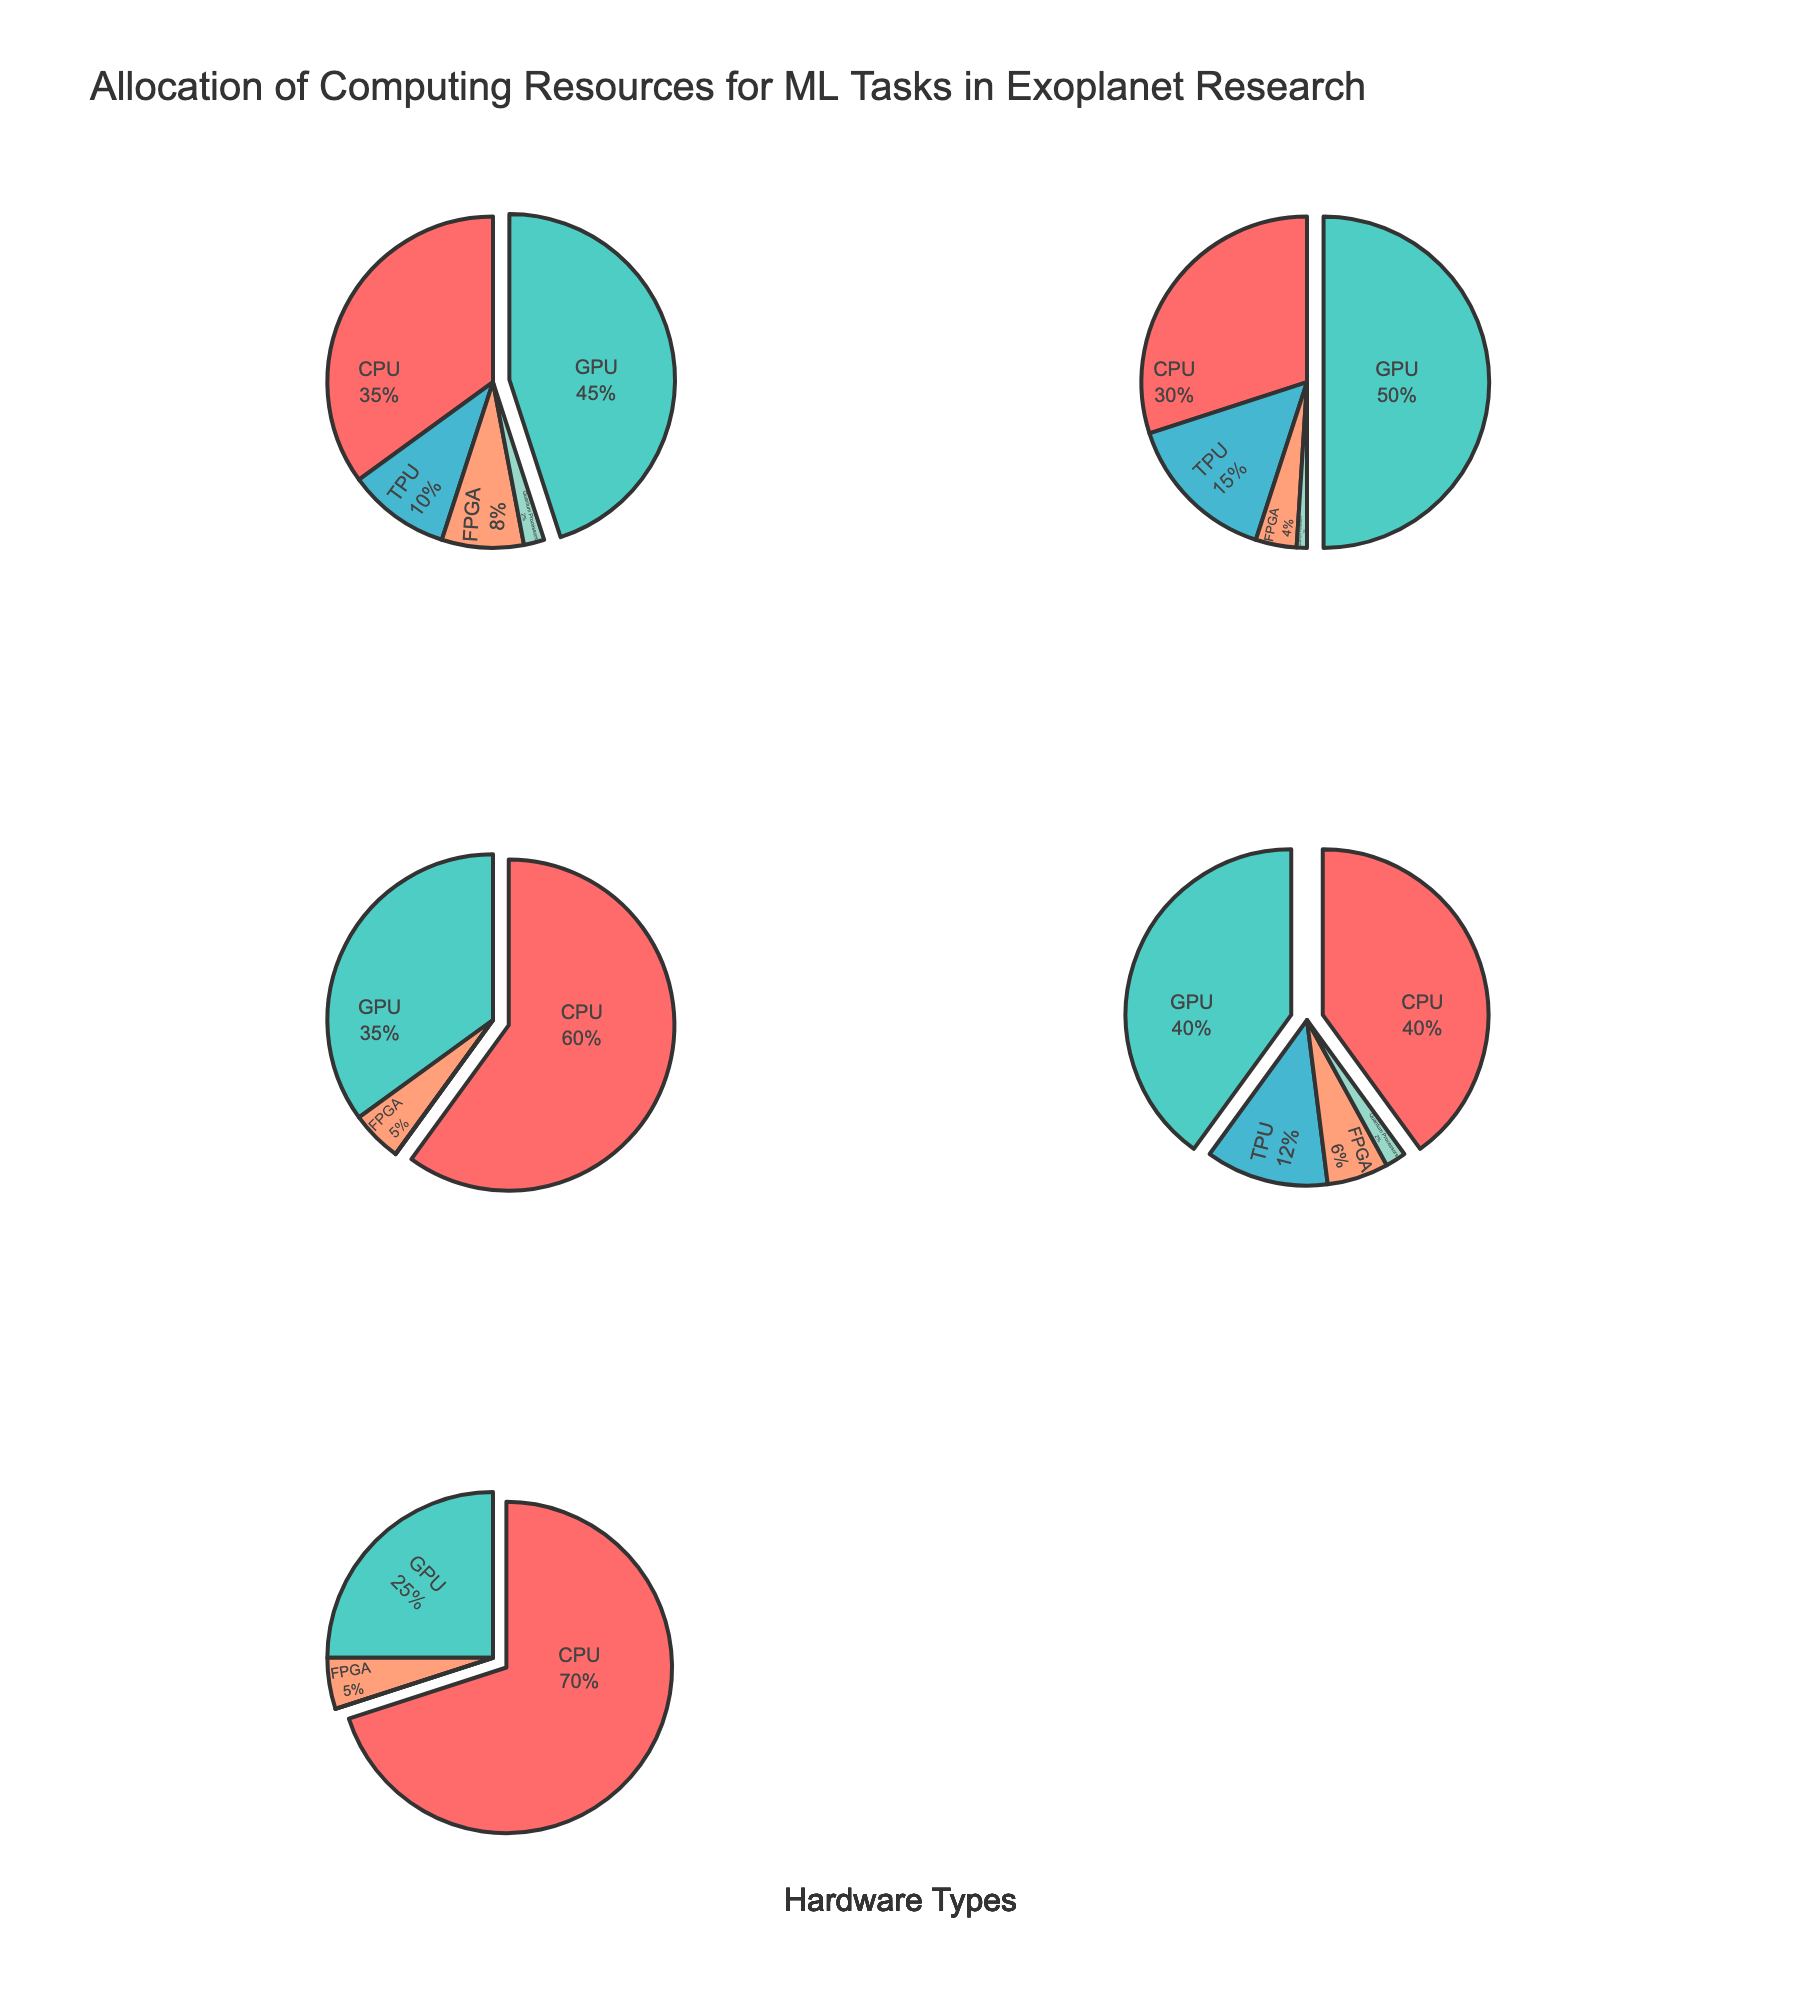What's the title of the figure? The title can usually be found at the top of the figure, it's a general description of what the figure represents.
Answer: Allocation of Computing Resources for ML Tasks in Exoplanet Research Which hardware type allocates the highest percentage of resources to GPUs? To find this, look for the pie chart slice with the largest percentage for GPUs in each subplot.
Answer: Cloud Computing Services What is the smallest percentage allocation for TPUs across all hardware types? Compare the TPU slices across all pie charts to find the smallest percentage.
Answer: 0% Between High-Performance Clusters and University Supercomputers, which allocates more resources to FPGAs? Compare the FPGA slices in these two specific pie charts.
Answer: High-Performance Clusters If you sum the CPU allocation percentages for Cloud Computing Services and On-Premises Workstations, what is the total? Sum the CPU percentages from the corresponding slices of these two hardware types: 30% + 60%.
Answer: 90% Which hardware type has the most balanced distribution across CPU, GPU, and TPU? Look for the pie chart where CPU, GPU, and TPU slices are most similar in size.
Answer: University Supercomputers How does the allocation of resources to Quantum Processors compare between Edge Devices for Data Collection and High-Performance Clusters? Compare the Quantum Processors slices between these two hardware types.
Answer: Both have the same percentage allocation (2%) What percentage do FPGAs constitute in the University Supercomputers? Identify the FPGA slice in the University Supercomputers pie chart and note its percentage.
Answer: 6% How many hardware types allocate resources to TPUs? Count the number of hardware types that have a non-zero TPU slice in their pie charts.
Answer: 4 hardware types What's the total percentage of resources allocated to CPUs and GPUs combined in the High-Performance Clusters? Add the percentages for CPUs and GPUs in the High-Performance Clusters: 35% (CPU) + 45% (GPU).
Answer: 80% 